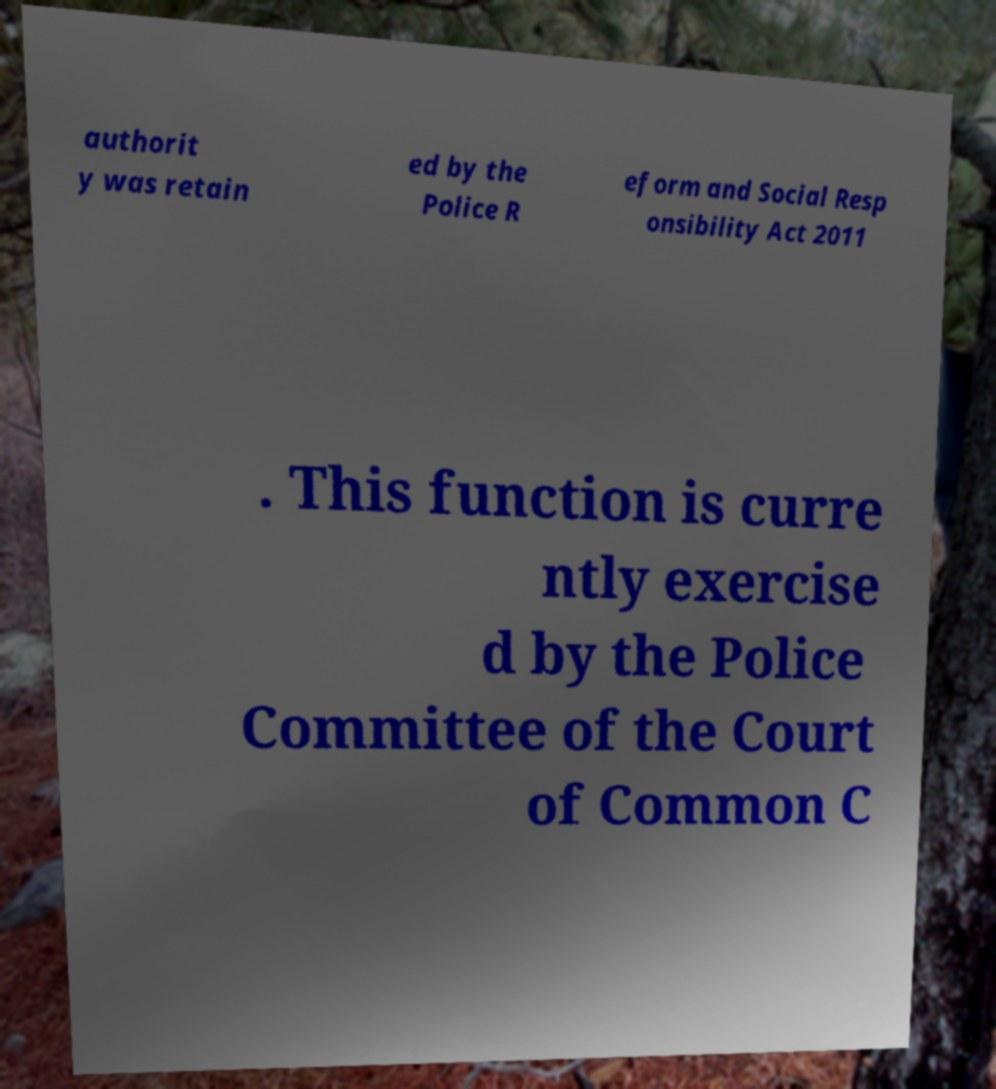I need the written content from this picture converted into text. Can you do that? authorit y was retain ed by the Police R eform and Social Resp onsibility Act 2011 . This function is curre ntly exercise d by the Police Committee of the Court of Common C 